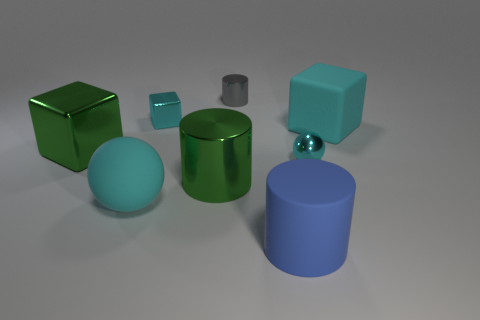There is a tiny cyan object in front of the large cyan block; is it the same shape as the tiny gray metallic thing?
Ensure brevity in your answer.  No. There is a large block to the right of the metallic cylinder on the left side of the metal cylinder behind the small cube; what is its color?
Ensure brevity in your answer.  Cyan. Are there any large blue matte cylinders?
Your answer should be very brief. Yes. What number of other objects are there of the same size as the blue rubber cylinder?
Your answer should be very brief. 4. Is the color of the large matte cube the same as the large cube to the left of the tiny cyan ball?
Give a very brief answer. No. What number of things are big cyan spheres or small purple metal things?
Offer a terse response. 1. Are there any other things of the same color as the tiny cylinder?
Your answer should be compact. No. Is the material of the green cube the same as the large cyan object that is behind the big green block?
Keep it short and to the point. No. What shape is the tiny cyan thing on the right side of the cylinder on the right side of the gray object?
Offer a terse response. Sphere. What is the shape of the cyan object that is on the left side of the big blue thing and to the right of the large cyan sphere?
Make the answer very short. Cube. 